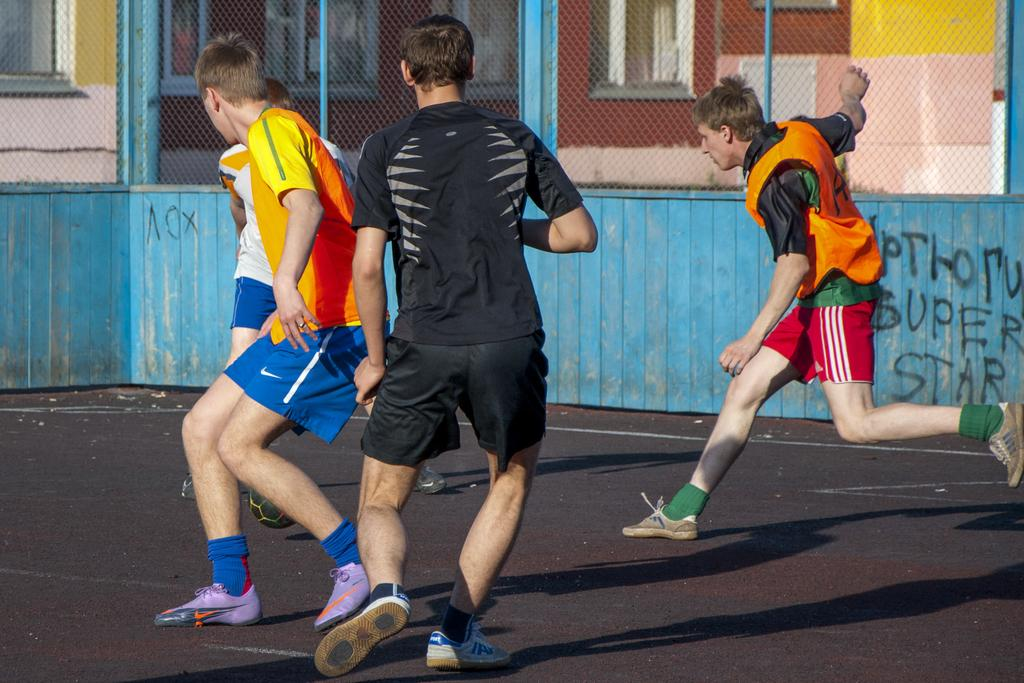<image>
Summarize the visual content of the image. Players playing a street soccer game near a blue wall that has SUPER STAR written on it. 